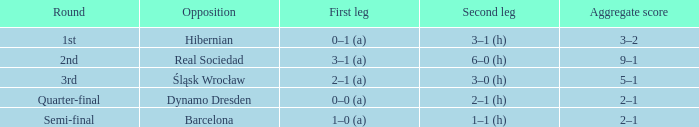What was the first leg of the semi-final? 1–0 (a). 